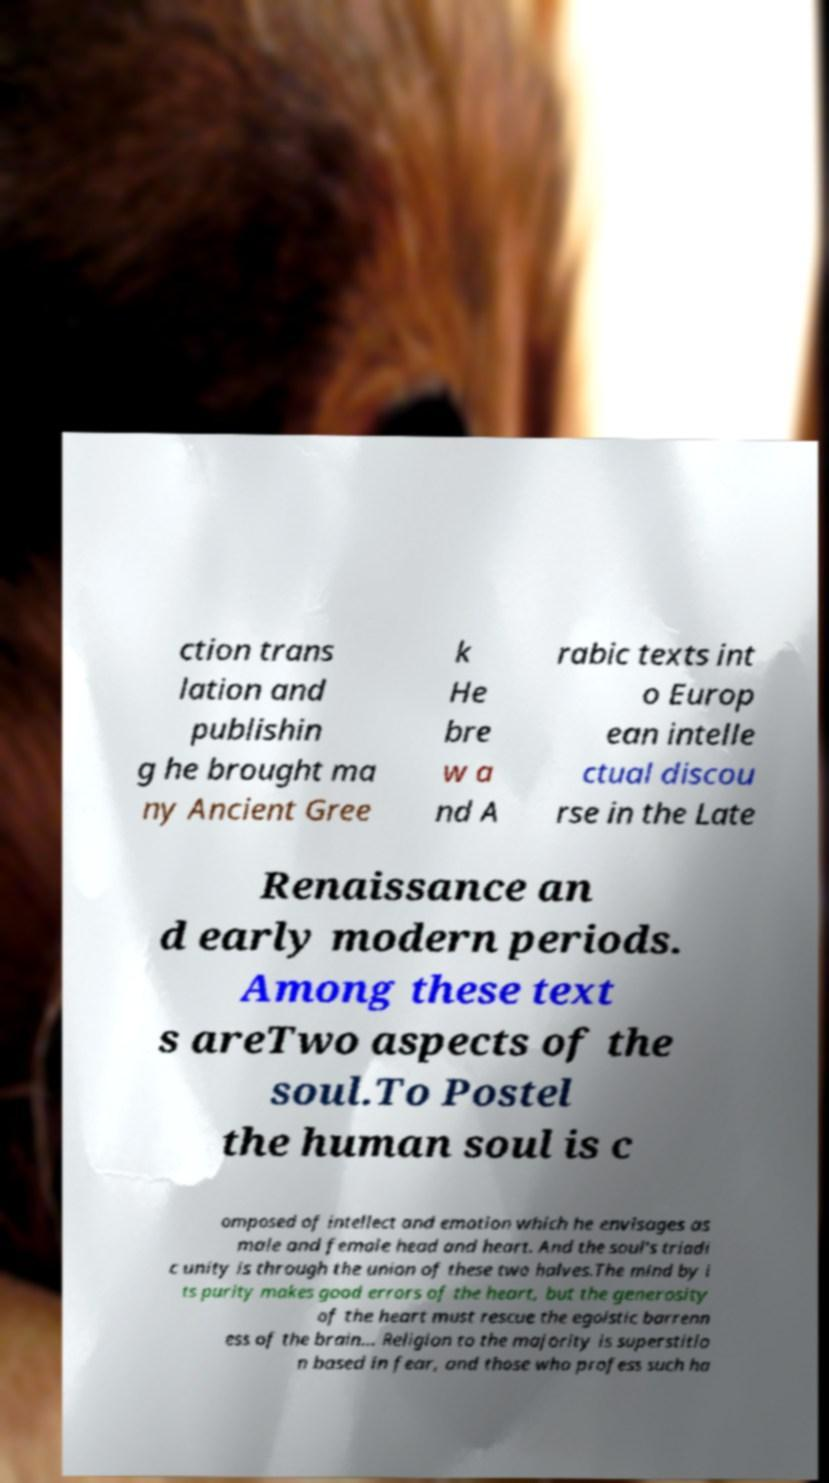Please identify and transcribe the text found in this image. ction trans lation and publishin g he brought ma ny Ancient Gree k He bre w a nd A rabic texts int o Europ ean intelle ctual discou rse in the Late Renaissance an d early modern periods. Among these text s areTwo aspects of the soul.To Postel the human soul is c omposed of intellect and emotion which he envisages as male and female head and heart. And the soul's triadi c unity is through the union of these two halves.The mind by i ts purity makes good errors of the heart, but the generosity of the heart must rescue the egoistic barrenn ess of the brain... Religion to the majority is superstitio n based in fear, and those who profess such ha 